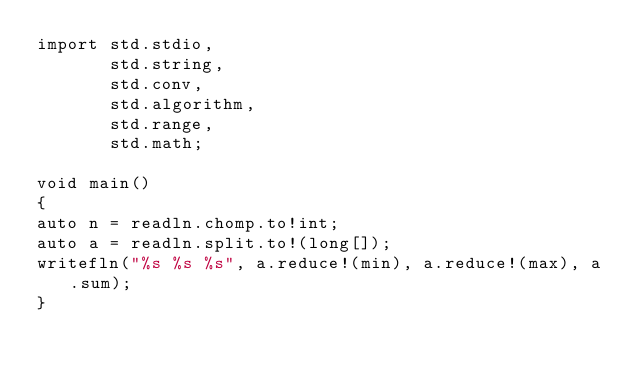Convert code to text. <code><loc_0><loc_0><loc_500><loc_500><_D_>import std.stdio,
	   std.string,
	   std.conv,
	   std.algorithm,
	   std.range,
	   std.math;

void main()
{
auto n = readln.chomp.to!int;
auto a = readln.split.to!(long[]);
writefln("%s %s %s", a.reduce!(min), a.reduce!(max), a.sum);
}
</code> 